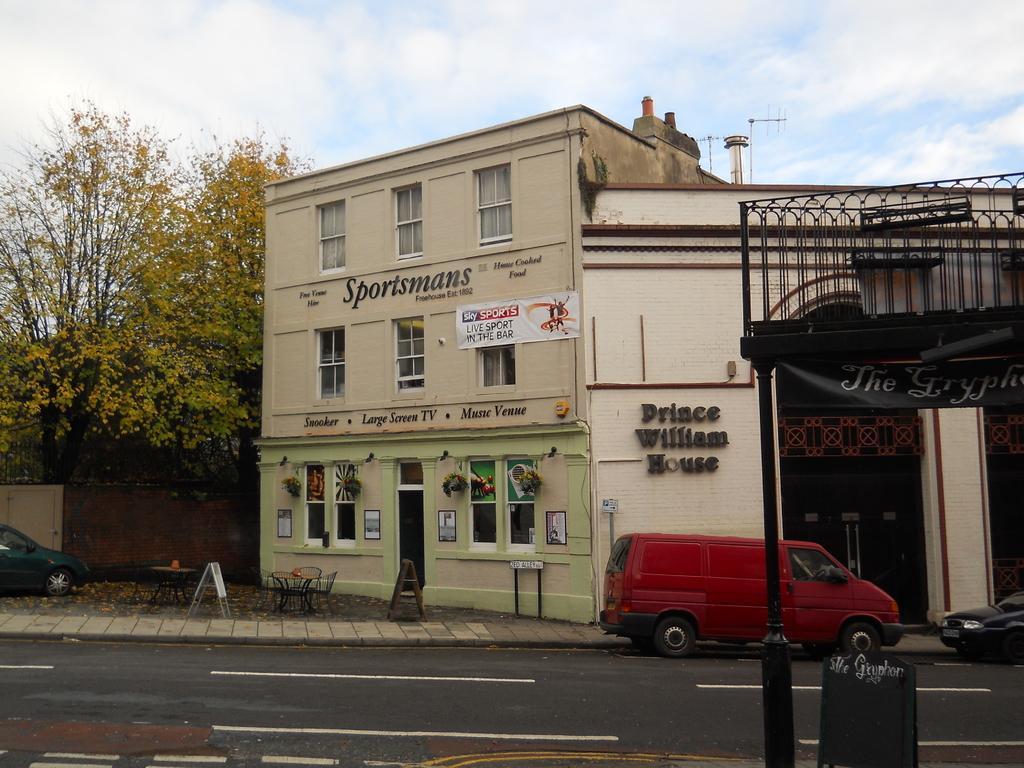Please provide a concise description of this image. In this image we can see the buildings, banners, railing, pole, boards, tables with the chairs. We can also see the vehicles, path and also the road. We can see the trees, wall, dried leaves and also the sky with the clouds. 